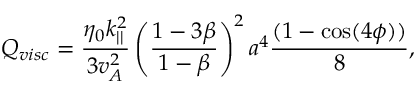Convert formula to latex. <formula><loc_0><loc_0><loc_500><loc_500>Q _ { v i s c } = \frac { \eta _ { 0 } k _ { | | } ^ { 2 } } { 3 v _ { A } ^ { 2 } } \left ( \frac { 1 - 3 \beta } { 1 - \beta } \right ) ^ { 2 } a ^ { 4 } \frac { ( 1 - \cos ( 4 \phi ) ) } { 8 } ,</formula> 